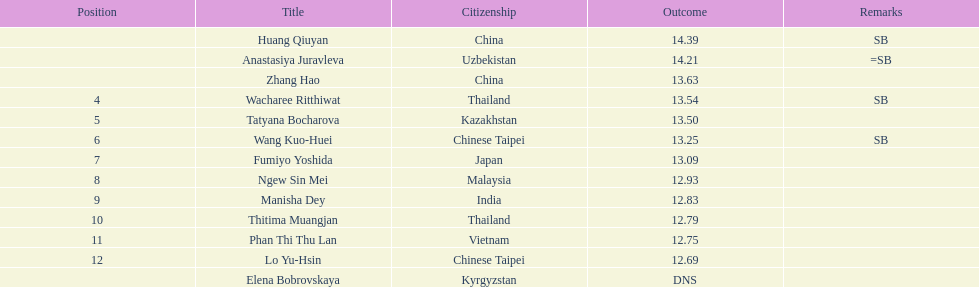What nationality was the woman who won first place? China. 